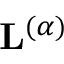Convert formula to latex. <formula><loc_0><loc_0><loc_500><loc_500>L ^ { ( \alpha ) }</formula> 